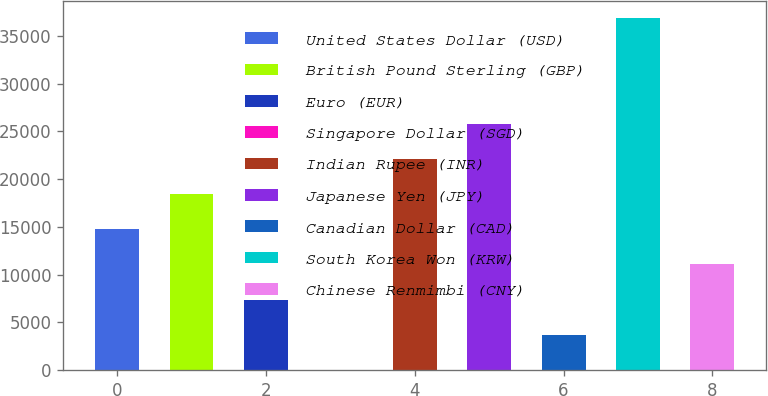Convert chart to OTSL. <chart><loc_0><loc_0><loc_500><loc_500><bar_chart><fcel>United States Dollar (USD)<fcel>British Pound Sterling (GBP)<fcel>Euro (EUR)<fcel>Singapore Dollar (SGD)<fcel>Indian Rupee (INR)<fcel>Japanese Yen (JPY)<fcel>Canadian Dollar (CAD)<fcel>South Korea Won (KRW)<fcel>Chinese Renmimbi (CNY)<nl><fcel>14745.2<fcel>18426.5<fcel>7382.6<fcel>20<fcel>22107.8<fcel>25789.1<fcel>3701.3<fcel>36833<fcel>11063.9<nl></chart> 